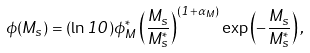Convert formula to latex. <formula><loc_0><loc_0><loc_500><loc_500>\phi ( M _ { s } ) = ( \ln 1 0 ) \phi _ { M } ^ { * } \left ( \frac { M _ { s } } { M _ { s } ^ { * } } \right ) ^ { ( 1 + \alpha _ { M } ) } \exp \left ( - \frac { M _ { s } } { M _ { s } ^ { * } } \right ) ,</formula> 